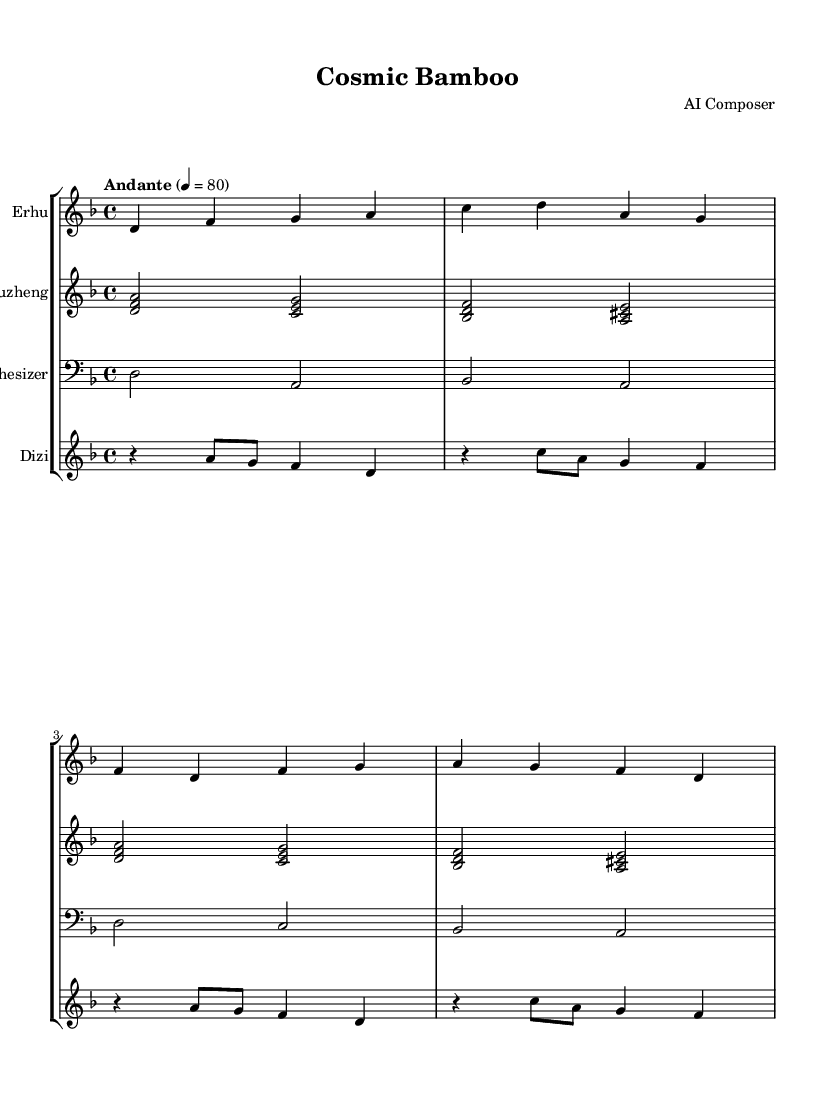What is the key signature of this music? The key signature is marked as D minor, which has one flat (B flat). This indicates that the piece is centered around the tonalities of the D minor scale.
Answer: D minor What is the time signature of this piece? The time signature is shown as 4/4, which means there are four beats in a measure and the quarter note receives one beat. This is a common time signature in music.
Answer: 4/4 What is the tempo marking of the composition? The tempo is indicated as "Andante" with a metronome marking of 80 beats per minute. "Andante" suggests a moderately slow pace, providing a relaxed feel to the music.
Answer: Andante, 80 How many instruments are featured in the score? The score contains four instrument parts, which are Erhu, Guzheng, Synthesizer, and Dizi. This blend showcases traditional and modern instruments together in this piece.
Answer: Four Which instrument has the lowest pitch in the score? The synthesizer is written in the bass clef, which typically represents lower pitches compared to the treble clef used for the other instruments. The pitches indicated in the synthesizer part are the lowest overall in the score.
Answer: Synthesizer What is the rhythmic pattern for the Dizi in the first measure? The Dizi part starts with a rest followed by two eighth notes and ends with a quarter note. This specific combination creates a unique rhythmic beginning that contrasts with the other instruments.
Answer: Rest, a, g, f, d 